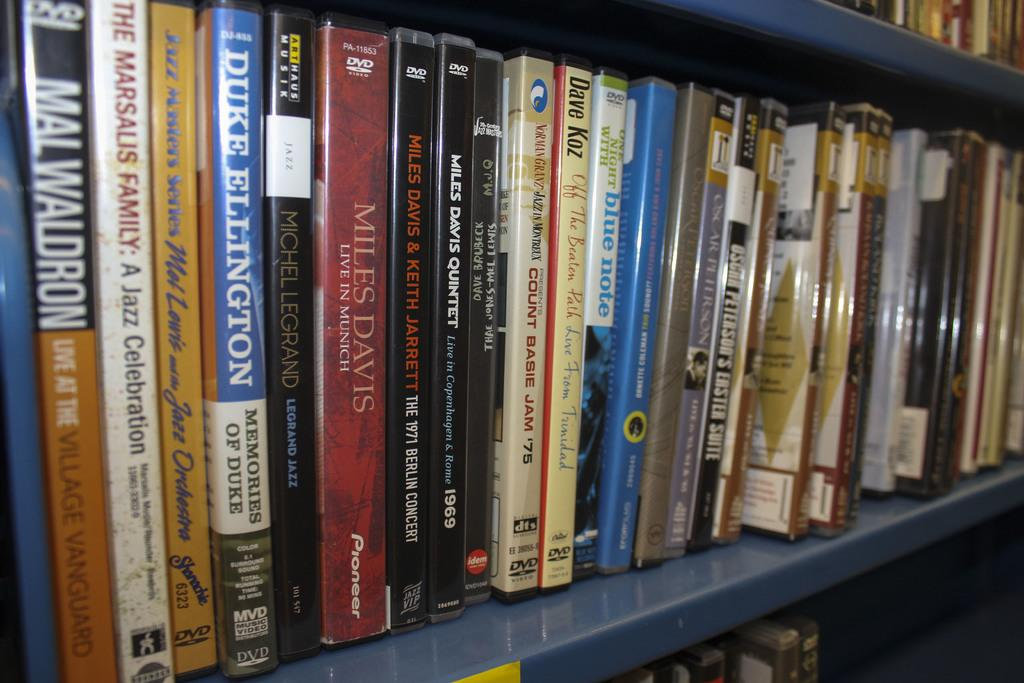<image>
Render a clear and concise summary of the photo. A row of dvds of music and one is by Duke Ellington. 